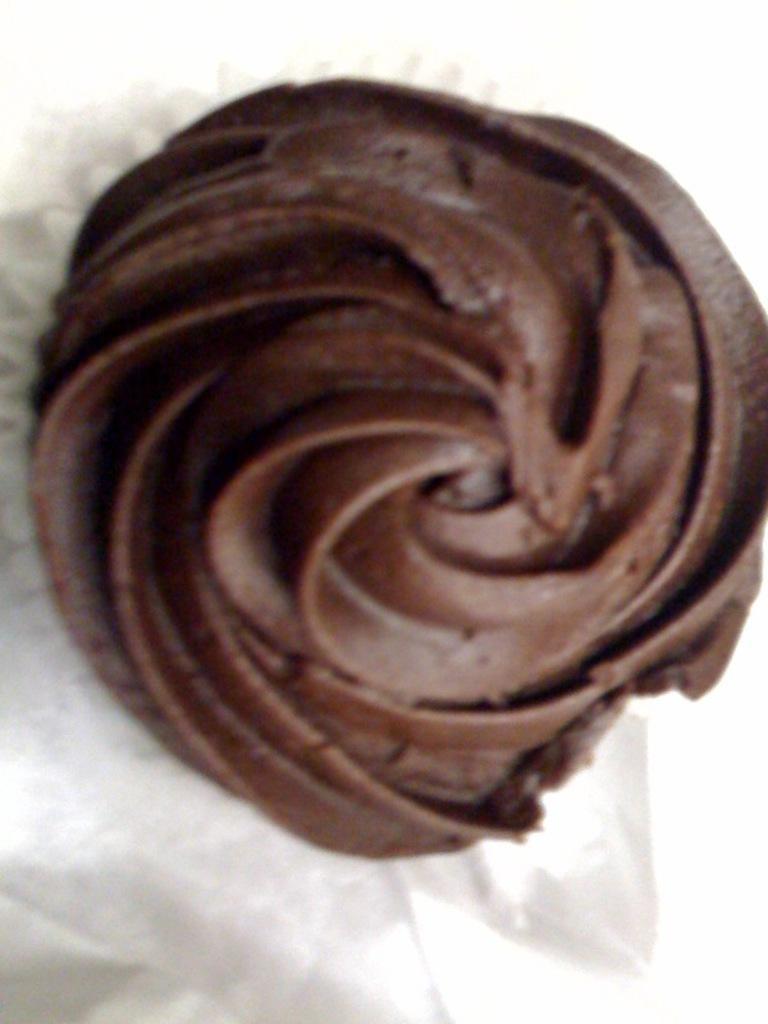Can you describe this image briefly? In this image, we can see a dessert. 